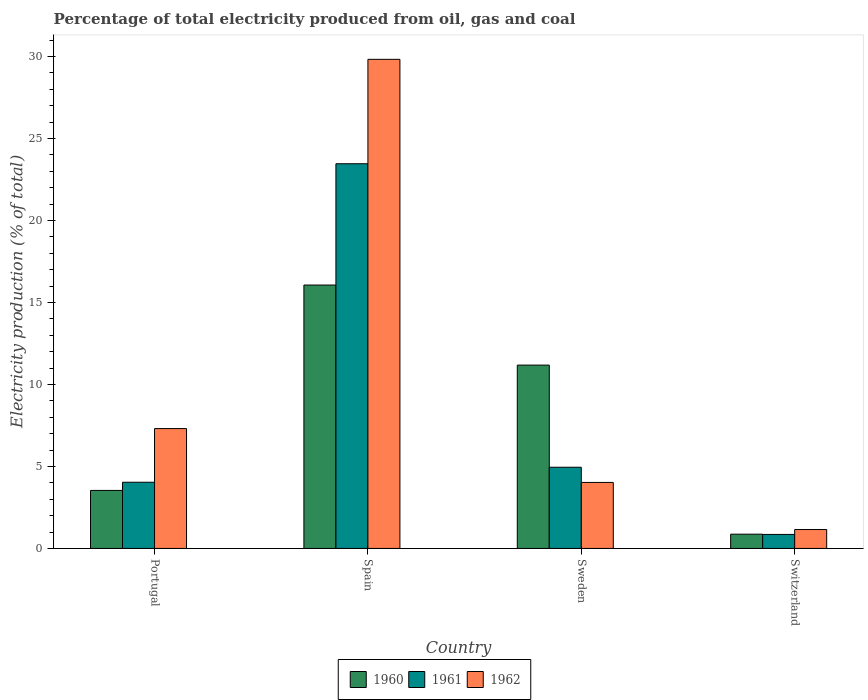How many different coloured bars are there?
Ensure brevity in your answer.  3. How many bars are there on the 1st tick from the left?
Offer a terse response. 3. In how many cases, is the number of bars for a given country not equal to the number of legend labels?
Make the answer very short. 0. What is the electricity production in in 1961 in Portugal?
Provide a short and direct response. 4.04. Across all countries, what is the maximum electricity production in in 1961?
Your answer should be very brief. 23.46. Across all countries, what is the minimum electricity production in in 1962?
Your response must be concise. 1.15. In which country was the electricity production in in 1962 maximum?
Your answer should be compact. Spain. In which country was the electricity production in in 1961 minimum?
Keep it short and to the point. Switzerland. What is the total electricity production in in 1961 in the graph?
Ensure brevity in your answer.  33.3. What is the difference between the electricity production in in 1961 in Spain and that in Switzerland?
Your response must be concise. 22.61. What is the difference between the electricity production in in 1962 in Portugal and the electricity production in in 1961 in Spain?
Provide a short and direct response. -16.15. What is the average electricity production in in 1961 per country?
Offer a terse response. 8.33. What is the difference between the electricity production in of/in 1962 and electricity production in of/in 1960 in Switzerland?
Your response must be concise. 0.28. In how many countries, is the electricity production in in 1961 greater than 24 %?
Offer a very short reply. 0. What is the ratio of the electricity production in in 1962 in Spain to that in Sweden?
Give a very brief answer. 7.41. Is the electricity production in in 1962 in Spain less than that in Sweden?
Your answer should be compact. No. Is the difference between the electricity production in in 1962 in Spain and Switzerland greater than the difference between the electricity production in in 1960 in Spain and Switzerland?
Ensure brevity in your answer.  Yes. What is the difference between the highest and the second highest electricity production in in 1961?
Offer a terse response. 0.92. What is the difference between the highest and the lowest electricity production in in 1962?
Make the answer very short. 28.67. What does the 2nd bar from the right in Sweden represents?
Your answer should be compact. 1961. How many bars are there?
Your response must be concise. 12. How many countries are there in the graph?
Ensure brevity in your answer.  4. Are the values on the major ticks of Y-axis written in scientific E-notation?
Ensure brevity in your answer.  No. Does the graph contain any zero values?
Provide a short and direct response. No. Where does the legend appear in the graph?
Give a very brief answer. Bottom center. How many legend labels are there?
Offer a very short reply. 3. How are the legend labels stacked?
Provide a succinct answer. Horizontal. What is the title of the graph?
Your response must be concise. Percentage of total electricity produced from oil, gas and coal. What is the label or title of the Y-axis?
Your answer should be compact. Electricity production (% of total). What is the Electricity production (% of total) in 1960 in Portugal?
Your answer should be very brief. 3.54. What is the Electricity production (% of total) in 1961 in Portugal?
Provide a short and direct response. 4.04. What is the Electricity production (% of total) of 1962 in Portugal?
Ensure brevity in your answer.  7.31. What is the Electricity production (% of total) of 1960 in Spain?
Offer a terse response. 16.06. What is the Electricity production (% of total) of 1961 in Spain?
Make the answer very short. 23.46. What is the Electricity production (% of total) in 1962 in Spain?
Your answer should be compact. 29.83. What is the Electricity production (% of total) in 1960 in Sweden?
Provide a succinct answer. 11.18. What is the Electricity production (% of total) of 1961 in Sweden?
Keep it short and to the point. 4.95. What is the Electricity production (% of total) in 1962 in Sweden?
Provide a succinct answer. 4.02. What is the Electricity production (% of total) in 1960 in Switzerland?
Your answer should be compact. 0.87. What is the Electricity production (% of total) in 1961 in Switzerland?
Give a very brief answer. 0.85. What is the Electricity production (% of total) in 1962 in Switzerland?
Provide a short and direct response. 1.15. Across all countries, what is the maximum Electricity production (% of total) in 1960?
Offer a terse response. 16.06. Across all countries, what is the maximum Electricity production (% of total) in 1961?
Make the answer very short. 23.46. Across all countries, what is the maximum Electricity production (% of total) in 1962?
Provide a short and direct response. 29.83. Across all countries, what is the minimum Electricity production (% of total) in 1960?
Offer a very short reply. 0.87. Across all countries, what is the minimum Electricity production (% of total) of 1961?
Ensure brevity in your answer.  0.85. Across all countries, what is the minimum Electricity production (% of total) of 1962?
Your answer should be compact. 1.15. What is the total Electricity production (% of total) of 1960 in the graph?
Your response must be concise. 31.65. What is the total Electricity production (% of total) of 1961 in the graph?
Ensure brevity in your answer.  33.3. What is the total Electricity production (% of total) of 1962 in the graph?
Provide a succinct answer. 42.31. What is the difference between the Electricity production (% of total) of 1960 in Portugal and that in Spain?
Keep it short and to the point. -12.53. What is the difference between the Electricity production (% of total) of 1961 in Portugal and that in Spain?
Provide a short and direct response. -19.42. What is the difference between the Electricity production (% of total) in 1962 in Portugal and that in Spain?
Your answer should be compact. -22.52. What is the difference between the Electricity production (% of total) of 1960 in Portugal and that in Sweden?
Your response must be concise. -7.64. What is the difference between the Electricity production (% of total) of 1961 in Portugal and that in Sweden?
Give a very brief answer. -0.92. What is the difference between the Electricity production (% of total) of 1962 in Portugal and that in Sweden?
Your answer should be very brief. 3.28. What is the difference between the Electricity production (% of total) in 1960 in Portugal and that in Switzerland?
Offer a terse response. 2.67. What is the difference between the Electricity production (% of total) in 1961 in Portugal and that in Switzerland?
Your response must be concise. 3.18. What is the difference between the Electricity production (% of total) in 1962 in Portugal and that in Switzerland?
Offer a very short reply. 6.16. What is the difference between the Electricity production (% of total) of 1960 in Spain and that in Sweden?
Ensure brevity in your answer.  4.88. What is the difference between the Electricity production (% of total) in 1961 in Spain and that in Sweden?
Keep it short and to the point. 18.51. What is the difference between the Electricity production (% of total) in 1962 in Spain and that in Sweden?
Make the answer very short. 25.8. What is the difference between the Electricity production (% of total) in 1960 in Spain and that in Switzerland?
Offer a terse response. 15.19. What is the difference between the Electricity production (% of total) in 1961 in Spain and that in Switzerland?
Offer a very short reply. 22.61. What is the difference between the Electricity production (% of total) in 1962 in Spain and that in Switzerland?
Make the answer very short. 28.67. What is the difference between the Electricity production (% of total) of 1960 in Sweden and that in Switzerland?
Provide a succinct answer. 10.31. What is the difference between the Electricity production (% of total) of 1961 in Sweden and that in Switzerland?
Ensure brevity in your answer.  4.1. What is the difference between the Electricity production (% of total) in 1962 in Sweden and that in Switzerland?
Your answer should be compact. 2.87. What is the difference between the Electricity production (% of total) of 1960 in Portugal and the Electricity production (% of total) of 1961 in Spain?
Provide a succinct answer. -19.92. What is the difference between the Electricity production (% of total) of 1960 in Portugal and the Electricity production (% of total) of 1962 in Spain?
Your response must be concise. -26.29. What is the difference between the Electricity production (% of total) in 1961 in Portugal and the Electricity production (% of total) in 1962 in Spain?
Make the answer very short. -25.79. What is the difference between the Electricity production (% of total) in 1960 in Portugal and the Electricity production (% of total) in 1961 in Sweden?
Your answer should be compact. -1.41. What is the difference between the Electricity production (% of total) of 1960 in Portugal and the Electricity production (% of total) of 1962 in Sweden?
Keep it short and to the point. -0.49. What is the difference between the Electricity production (% of total) in 1961 in Portugal and the Electricity production (% of total) in 1962 in Sweden?
Make the answer very short. 0.01. What is the difference between the Electricity production (% of total) in 1960 in Portugal and the Electricity production (% of total) in 1961 in Switzerland?
Provide a succinct answer. 2.68. What is the difference between the Electricity production (% of total) in 1960 in Portugal and the Electricity production (% of total) in 1962 in Switzerland?
Keep it short and to the point. 2.38. What is the difference between the Electricity production (% of total) of 1961 in Portugal and the Electricity production (% of total) of 1962 in Switzerland?
Your answer should be compact. 2.88. What is the difference between the Electricity production (% of total) in 1960 in Spain and the Electricity production (% of total) in 1961 in Sweden?
Offer a terse response. 11.11. What is the difference between the Electricity production (% of total) of 1960 in Spain and the Electricity production (% of total) of 1962 in Sweden?
Your response must be concise. 12.04. What is the difference between the Electricity production (% of total) of 1961 in Spain and the Electricity production (% of total) of 1962 in Sweden?
Offer a terse response. 19.44. What is the difference between the Electricity production (% of total) in 1960 in Spain and the Electricity production (% of total) in 1961 in Switzerland?
Keep it short and to the point. 15.21. What is the difference between the Electricity production (% of total) in 1960 in Spain and the Electricity production (% of total) in 1962 in Switzerland?
Give a very brief answer. 14.91. What is the difference between the Electricity production (% of total) in 1961 in Spain and the Electricity production (% of total) in 1962 in Switzerland?
Provide a succinct answer. 22.31. What is the difference between the Electricity production (% of total) in 1960 in Sweden and the Electricity production (% of total) in 1961 in Switzerland?
Keep it short and to the point. 10.33. What is the difference between the Electricity production (% of total) in 1960 in Sweden and the Electricity production (% of total) in 1962 in Switzerland?
Your answer should be compact. 10.03. What is the difference between the Electricity production (% of total) of 1961 in Sweden and the Electricity production (% of total) of 1962 in Switzerland?
Keep it short and to the point. 3.8. What is the average Electricity production (% of total) of 1960 per country?
Your answer should be very brief. 7.91. What is the average Electricity production (% of total) of 1961 per country?
Give a very brief answer. 8.33. What is the average Electricity production (% of total) in 1962 per country?
Keep it short and to the point. 10.58. What is the difference between the Electricity production (% of total) of 1960 and Electricity production (% of total) of 1961 in Portugal?
Offer a very short reply. -0.5. What is the difference between the Electricity production (% of total) in 1960 and Electricity production (% of total) in 1962 in Portugal?
Give a very brief answer. -3.77. What is the difference between the Electricity production (% of total) in 1961 and Electricity production (% of total) in 1962 in Portugal?
Your response must be concise. -3.27. What is the difference between the Electricity production (% of total) of 1960 and Electricity production (% of total) of 1961 in Spain?
Provide a short and direct response. -7.4. What is the difference between the Electricity production (% of total) of 1960 and Electricity production (% of total) of 1962 in Spain?
Your answer should be compact. -13.76. What is the difference between the Electricity production (% of total) of 1961 and Electricity production (% of total) of 1962 in Spain?
Ensure brevity in your answer.  -6.37. What is the difference between the Electricity production (% of total) in 1960 and Electricity production (% of total) in 1961 in Sweden?
Make the answer very short. 6.23. What is the difference between the Electricity production (% of total) of 1960 and Electricity production (% of total) of 1962 in Sweden?
Offer a terse response. 7.16. What is the difference between the Electricity production (% of total) in 1961 and Electricity production (% of total) in 1962 in Sweden?
Offer a very short reply. 0.93. What is the difference between the Electricity production (% of total) of 1960 and Electricity production (% of total) of 1961 in Switzerland?
Make the answer very short. 0.02. What is the difference between the Electricity production (% of total) of 1960 and Electricity production (% of total) of 1962 in Switzerland?
Make the answer very short. -0.28. What is the difference between the Electricity production (% of total) of 1961 and Electricity production (% of total) of 1962 in Switzerland?
Ensure brevity in your answer.  -0.3. What is the ratio of the Electricity production (% of total) in 1960 in Portugal to that in Spain?
Your answer should be very brief. 0.22. What is the ratio of the Electricity production (% of total) of 1961 in Portugal to that in Spain?
Keep it short and to the point. 0.17. What is the ratio of the Electricity production (% of total) of 1962 in Portugal to that in Spain?
Provide a succinct answer. 0.24. What is the ratio of the Electricity production (% of total) in 1960 in Portugal to that in Sweden?
Give a very brief answer. 0.32. What is the ratio of the Electricity production (% of total) of 1961 in Portugal to that in Sweden?
Make the answer very short. 0.82. What is the ratio of the Electricity production (% of total) in 1962 in Portugal to that in Sweden?
Your answer should be compact. 1.82. What is the ratio of the Electricity production (% of total) in 1960 in Portugal to that in Switzerland?
Provide a succinct answer. 4.07. What is the ratio of the Electricity production (% of total) of 1961 in Portugal to that in Switzerland?
Keep it short and to the point. 4.73. What is the ratio of the Electricity production (% of total) of 1962 in Portugal to that in Switzerland?
Make the answer very short. 6.34. What is the ratio of the Electricity production (% of total) in 1960 in Spain to that in Sweden?
Make the answer very short. 1.44. What is the ratio of the Electricity production (% of total) of 1961 in Spain to that in Sweden?
Ensure brevity in your answer.  4.74. What is the ratio of the Electricity production (% of total) of 1962 in Spain to that in Sweden?
Provide a short and direct response. 7.41. What is the ratio of the Electricity production (% of total) in 1960 in Spain to that in Switzerland?
Your answer should be compact. 18.47. What is the ratio of the Electricity production (% of total) in 1961 in Spain to that in Switzerland?
Offer a very short reply. 27.48. What is the ratio of the Electricity production (% of total) in 1962 in Spain to that in Switzerland?
Your response must be concise. 25.86. What is the ratio of the Electricity production (% of total) of 1960 in Sweden to that in Switzerland?
Your answer should be compact. 12.86. What is the ratio of the Electricity production (% of total) of 1961 in Sweden to that in Switzerland?
Your answer should be compact. 5.8. What is the ratio of the Electricity production (% of total) of 1962 in Sweden to that in Switzerland?
Make the answer very short. 3.49. What is the difference between the highest and the second highest Electricity production (% of total) of 1960?
Your answer should be very brief. 4.88. What is the difference between the highest and the second highest Electricity production (% of total) in 1961?
Ensure brevity in your answer.  18.51. What is the difference between the highest and the second highest Electricity production (% of total) in 1962?
Provide a succinct answer. 22.52. What is the difference between the highest and the lowest Electricity production (% of total) of 1960?
Provide a short and direct response. 15.19. What is the difference between the highest and the lowest Electricity production (% of total) of 1961?
Offer a very short reply. 22.61. What is the difference between the highest and the lowest Electricity production (% of total) in 1962?
Ensure brevity in your answer.  28.67. 